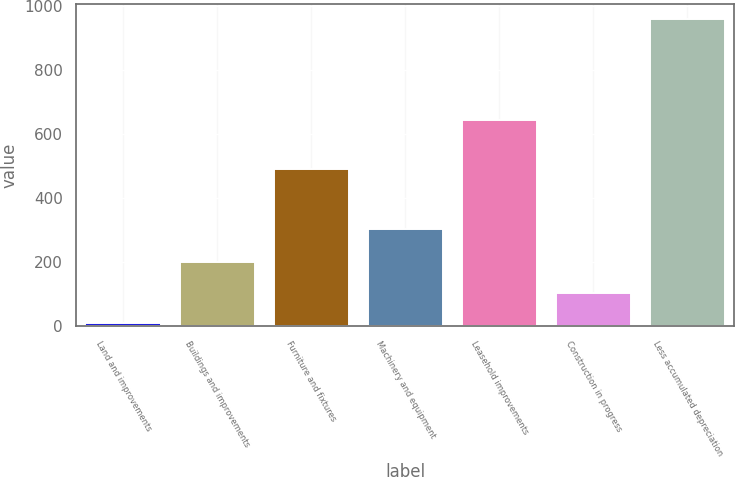<chart> <loc_0><loc_0><loc_500><loc_500><bar_chart><fcel>Land and improvements<fcel>Buildings and improvements<fcel>Furniture and fixtures<fcel>Machinery and equipment<fcel>Leasehold improvements<fcel>Construction in progress<fcel>Less accumulated depreciation<nl><fcel>9.9<fcel>199.9<fcel>491.1<fcel>305<fcel>643.3<fcel>104.9<fcel>959.9<nl></chart> 